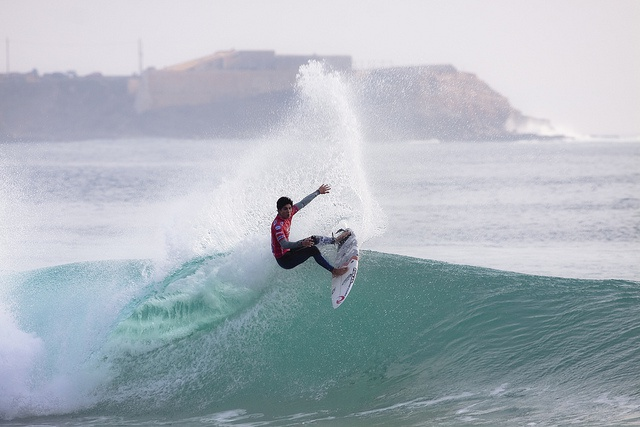Describe the objects in this image and their specific colors. I can see people in lightgray, black, gray, maroon, and darkgray tones and surfboard in lightgray, darkgray, and gray tones in this image. 